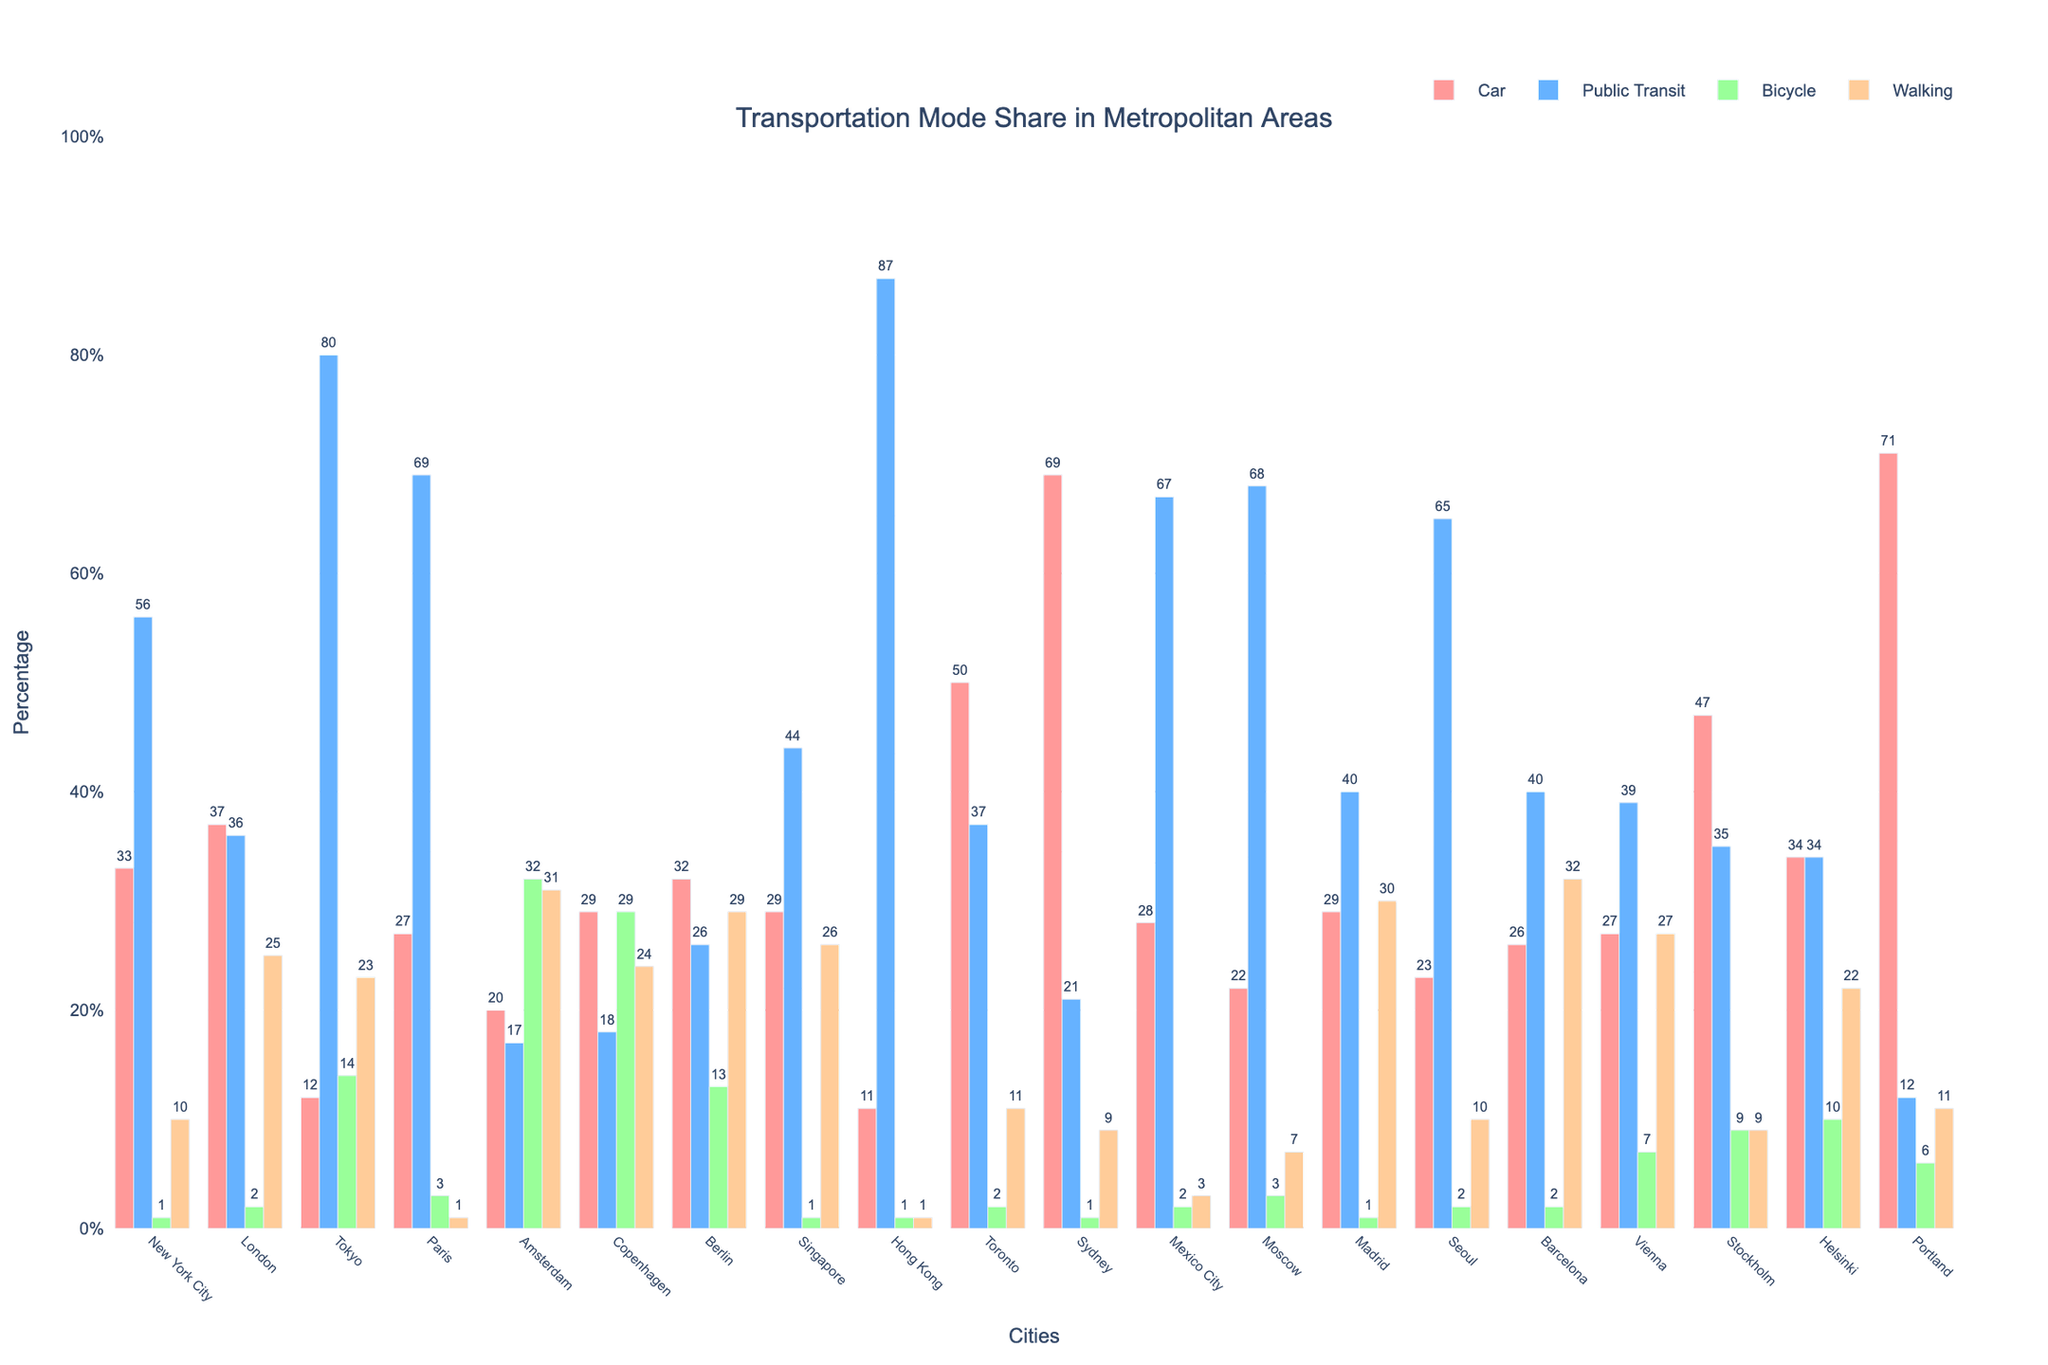Which city has the highest percentage of people using public transit? Look at the bar heights for the "Public Transit" category across all cities. New York City has the highest bar in this category.
Answer: Hong Kong Which city has the lowest percentage of people using cars? Compare the bar heights for the "Car" category across all cities and identify the shortest bar.
Answer: Hong Kong How much higher is the percentage of bicycling in Amsterdam compared to Tokyo? Look at the heights of the "Bicycle" bars for both Amsterdam and Tokyo. The bicycle percentage in Amsterdam is 32% and in Tokyo is 14%. Calculate the difference: 32% - 14% = 18%.
Answer: 18% Rank the top three cities for walking as a mode of transportation. Compare the bar heights in the "Walking" category for all cities. The cities with the highest percentages are Barcelona (32%), Amsterdam (31%), and Vienna (27%).
Answer: Barcelona, Amsterdam, Vienna What is the combined percentage of car and bicycle users in Copenhagen? Look at the heights of the "Car" and "Bicycle" bars for Copenhagen. The car percentage is 29% and the bicycle percentage is 29%. Sum them up: 29% + 29% = 58%.
Answer: 58% Which city has the closest percentage of public transit users to London? Compare the percentage of public transit users in London (36%) to other cities. Vienna has the closest percentage with 39%.
Answer: Vienna How does the percentage of walking in Paris compare to Hong Kong? Compare the bar heights for the "Walking" category of both cities. Paris has 1% walking, while Hong Kong also has 1%.
Answer: Equal Which city has the most evenly distributed mode shares? Look for the city where the bar heights across all four categories (Car, Public Transit, Bicycle, Walking) appear to be the most similar. Helsinki shows near-equal bar heights across all modes.
Answer: Helsinki 